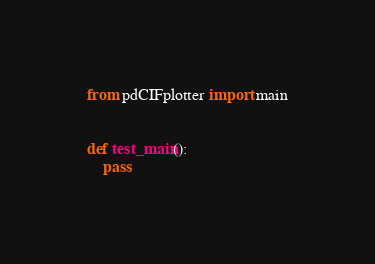Convert code to text. <code><loc_0><loc_0><loc_500><loc_500><_Python_>
from pdCIFplotter import main


def test_main():
    pass
</code> 